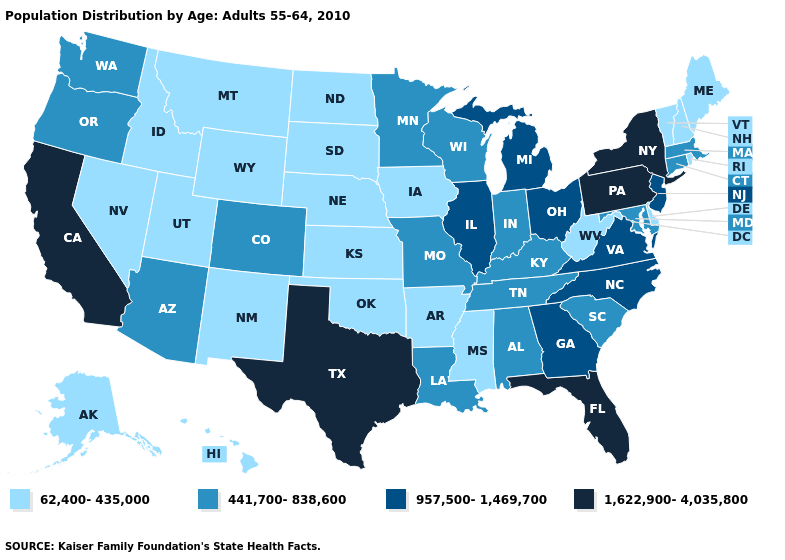What is the lowest value in states that border Wisconsin?
Write a very short answer. 62,400-435,000. What is the value of Ohio?
Quick response, please. 957,500-1,469,700. Among the states that border Indiana , does Illinois have the lowest value?
Quick response, please. No. Does Kansas have the lowest value in the MidWest?
Short answer required. Yes. What is the value of Virginia?
Keep it brief. 957,500-1,469,700. Does Texas have the highest value in the South?
Be succinct. Yes. Among the states that border Colorado , which have the lowest value?
Quick response, please. Kansas, Nebraska, New Mexico, Oklahoma, Utah, Wyoming. Does the first symbol in the legend represent the smallest category?
Give a very brief answer. Yes. Name the states that have a value in the range 957,500-1,469,700?
Short answer required. Georgia, Illinois, Michigan, New Jersey, North Carolina, Ohio, Virginia. What is the value of Arkansas?
Keep it brief. 62,400-435,000. Does Arkansas have the lowest value in the South?
Concise answer only. Yes. Among the states that border Maine , which have the highest value?
Give a very brief answer. New Hampshire. What is the lowest value in states that border Vermont?
Short answer required. 62,400-435,000. Which states hav the highest value in the MidWest?
Give a very brief answer. Illinois, Michigan, Ohio. Does West Virginia have the same value as Wyoming?
Quick response, please. Yes. 